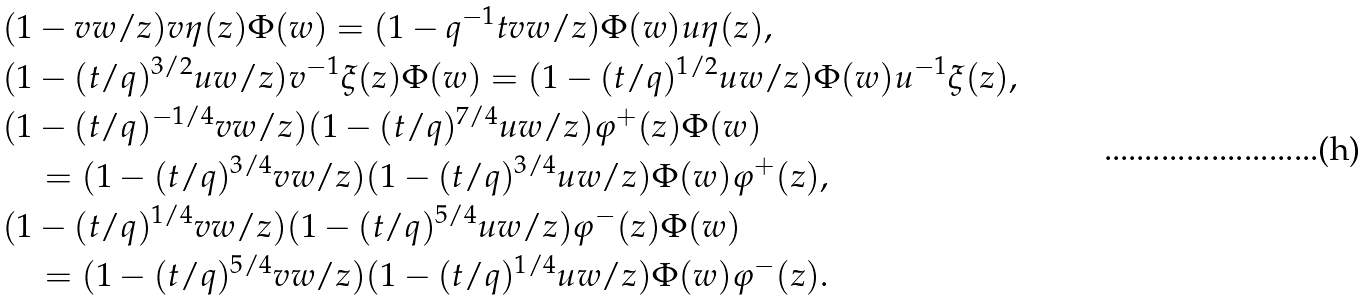Convert formula to latex. <formula><loc_0><loc_0><loc_500><loc_500>& ( 1 - v w / z ) v \eta ( z ) \Phi ( w ) = ( 1 - q ^ { - 1 } t v w / z ) \Phi ( w ) u \eta ( z ) , \\ & ( 1 - ( t / q ) ^ { 3 / 2 } u w / z ) v ^ { - 1 } \xi ( z ) \Phi ( w ) = ( 1 - ( t / q ) ^ { 1 / 2 } u w / z ) \Phi ( w ) u ^ { - 1 } \xi ( z ) , \\ & ( 1 - ( t / q ) ^ { - 1 / 4 } v w / z ) ( 1 - ( t / q ) ^ { 7 / 4 } u w / z ) \varphi ^ { + } ( z ) \Phi ( w ) \\ & \quad = ( 1 - ( t / q ) ^ { 3 / 4 } v w / z ) ( 1 - ( t / q ) ^ { 3 / 4 } u w / z ) \Phi ( w ) \varphi ^ { + } ( z ) , \\ & ( 1 - ( t / q ) ^ { 1 / 4 } v w / z ) ( 1 - ( t / q ) ^ { 5 / 4 } u w / z ) \varphi ^ { - } ( z ) \Phi ( w ) \\ & \quad = ( 1 - ( t / q ) ^ { 5 / 4 } v w / z ) ( 1 - ( t / q ) ^ { 1 / 4 } u w / z ) \Phi ( w ) \varphi ^ { - } ( z ) .</formula> 